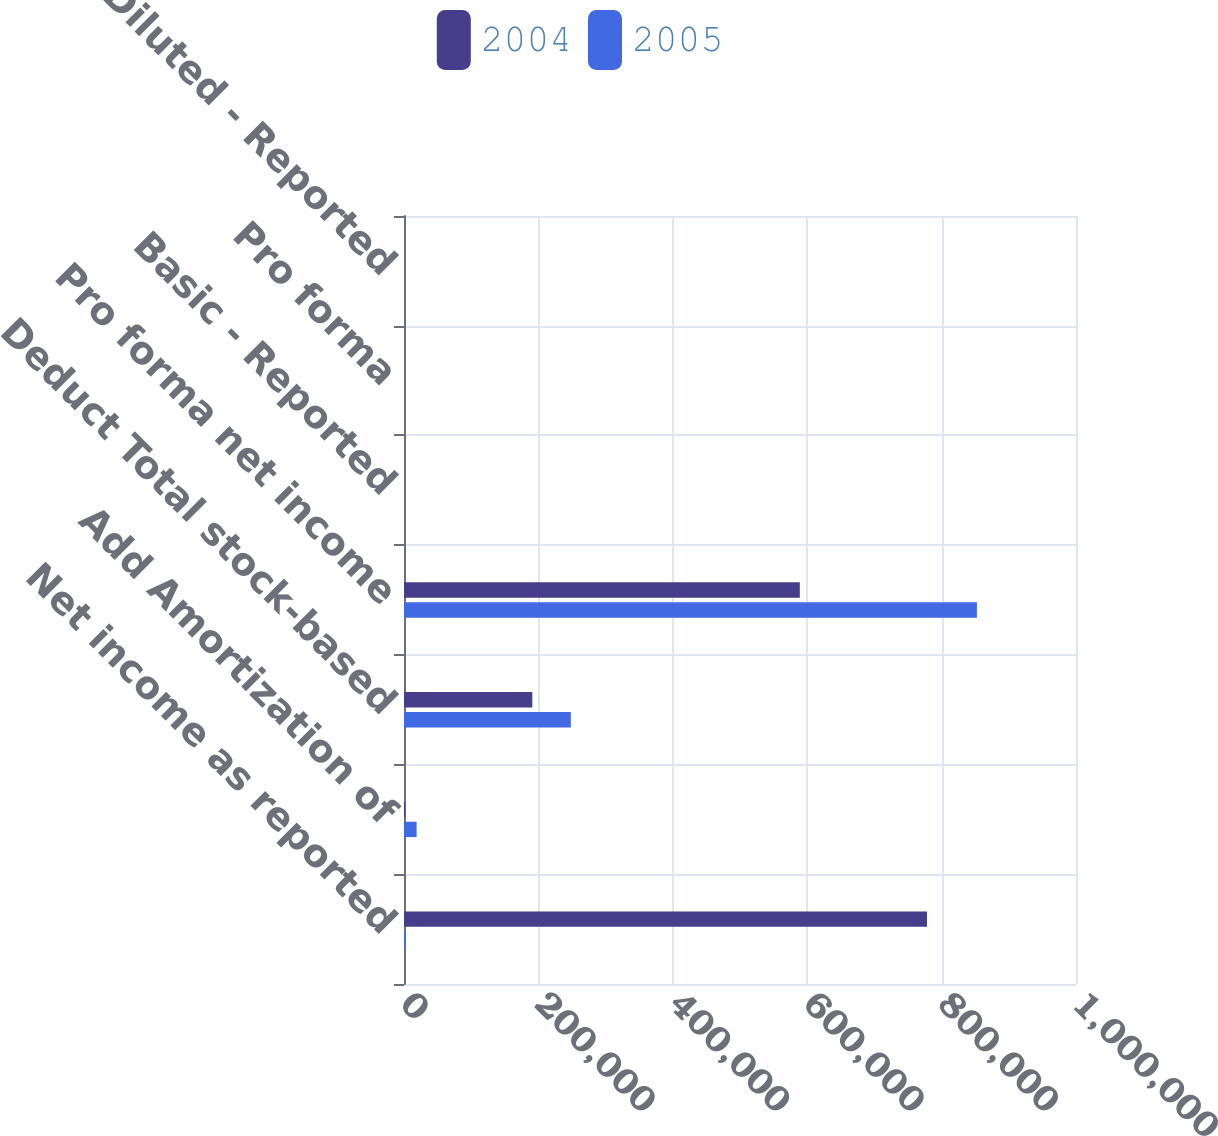Convert chart to OTSL. <chart><loc_0><loc_0><loc_500><loc_500><stacked_bar_chart><ecel><fcel>Net income as reported<fcel>Add Amortization of<fcel>Deduct Total stock-based<fcel>Pro forma net income<fcel>Basic - Reported<fcel>Pro forma<fcel>Diluted - Reported<nl><fcel>2004<fcel>778223<fcel>1715<fcel>190935<fcel>589003<fcel>0.59<fcel>0.45<fcel>0.57<nl><fcel>2005<fcel>1715<fcel>18749<fcel>248260<fcel>852532<fcel>0.79<fcel>0.63<fcel>0.78<nl></chart> 